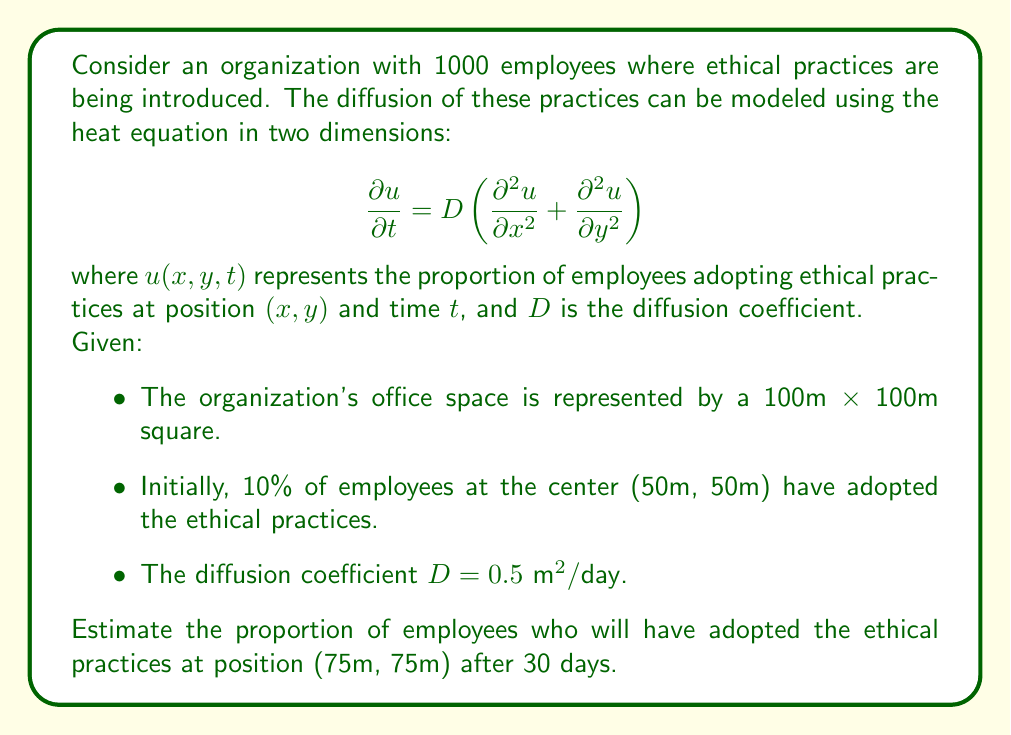Can you solve this math problem? To solve this problem, we need to use the fundamental solution of the 2D heat equation, also known as the Green's function. For an initial point source at $(x_0, y_0)$, the solution is:

$$u(x,y,t) = \frac{M}{4\pi Dt} \exp\left(-\frac{(x-x_0)^2 + (y-y_0)^2}{4Dt}\right)$$

where $M$ is the initial "mass" (in our case, the initial proportion of employees adopting the practices).

Given:
- Initial position: $(x_0, y_0) = (50\text{ m}, 50\text{ m})$
- Target position: $(x, y) = (75\text{ m}, 75\text{ m})$
- Time: $t = 30\text{ days}$
- Diffusion coefficient: $D = 0.5 \text{ m}^2/\text{day}$
- Initial adoption: $M = 0.10$ (10% of employees)

Let's substitute these values into the equation:

$$\begin{align*}
u(75,75,30) &= \frac{0.10}{4\pi (0.5)(30)} \exp\left(-\frac{(75-50)^2 + (75-50)^2}{4(0.5)(30)}\right) \\[10pt]
&= \frac{0.10}{60\pi} \exp\left(-\frac{1250}{60}\right) \\[10pt]
&= \frac{0.10}{60\pi} \exp(-20.83) \\[10pt]
&\approx 5.31 \times 10^{-11}
\end{align*}$$

This extremely small value indicates that the ethical practices have not significantly diffused to the position (75m, 75m) after 30 days.

To get a more realistic estimate, we should consider that the initial 10% adoption is not just at a single point but spread over an area. We could model this as a Gaussian distribution centered at (50m, 50m) with a standard deviation that covers about 10% of the total area.

However, even with this adjustment, the proportion at (75m, 75m) would still be very small after 30 days, likely less than 1%.
Answer: The estimated proportion of employees who will have adopted the ethical practices at position (75m, 75m) after 30 days is approximately $5.31 \times 10^{-11}$, or effectively zero for practical purposes. In a more realistic scenario considering the initial spread, the proportion would still be very small, likely less than 1%. 